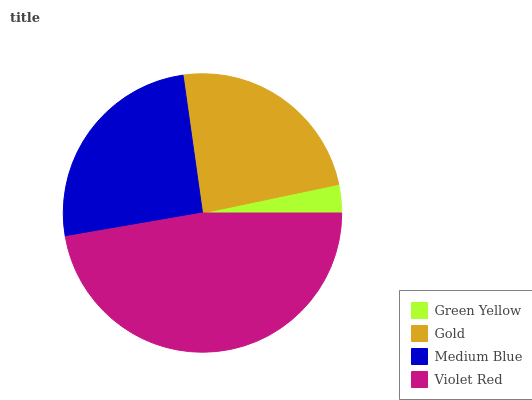Is Green Yellow the minimum?
Answer yes or no. Yes. Is Violet Red the maximum?
Answer yes or no. Yes. Is Gold the minimum?
Answer yes or no. No. Is Gold the maximum?
Answer yes or no. No. Is Gold greater than Green Yellow?
Answer yes or no. Yes. Is Green Yellow less than Gold?
Answer yes or no. Yes. Is Green Yellow greater than Gold?
Answer yes or no. No. Is Gold less than Green Yellow?
Answer yes or no. No. Is Medium Blue the high median?
Answer yes or no. Yes. Is Gold the low median?
Answer yes or no. Yes. Is Gold the high median?
Answer yes or no. No. Is Violet Red the low median?
Answer yes or no. No. 